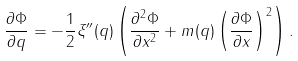<formula> <loc_0><loc_0><loc_500><loc_500>\frac { \partial \Phi } { \partial q } = - \frac { 1 } { 2 } \xi ^ { \prime \prime } ( q ) \left ( \frac { \partial ^ { 2 } \Phi } { \partial x ^ { 2 } } + m ( q ) \left ( \frac { \partial \Phi } { \partial x } \right ) ^ { 2 } \right ) .</formula> 